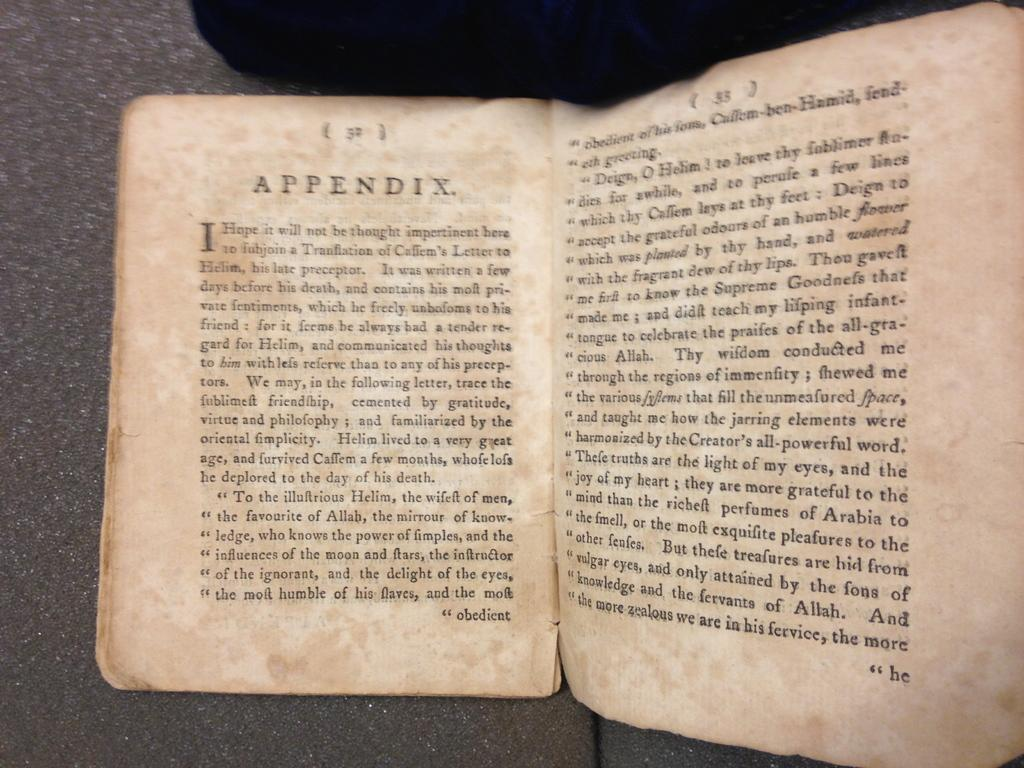<image>
Present a compact description of the photo's key features. A book is open to the appendix, which starts on page 32. 